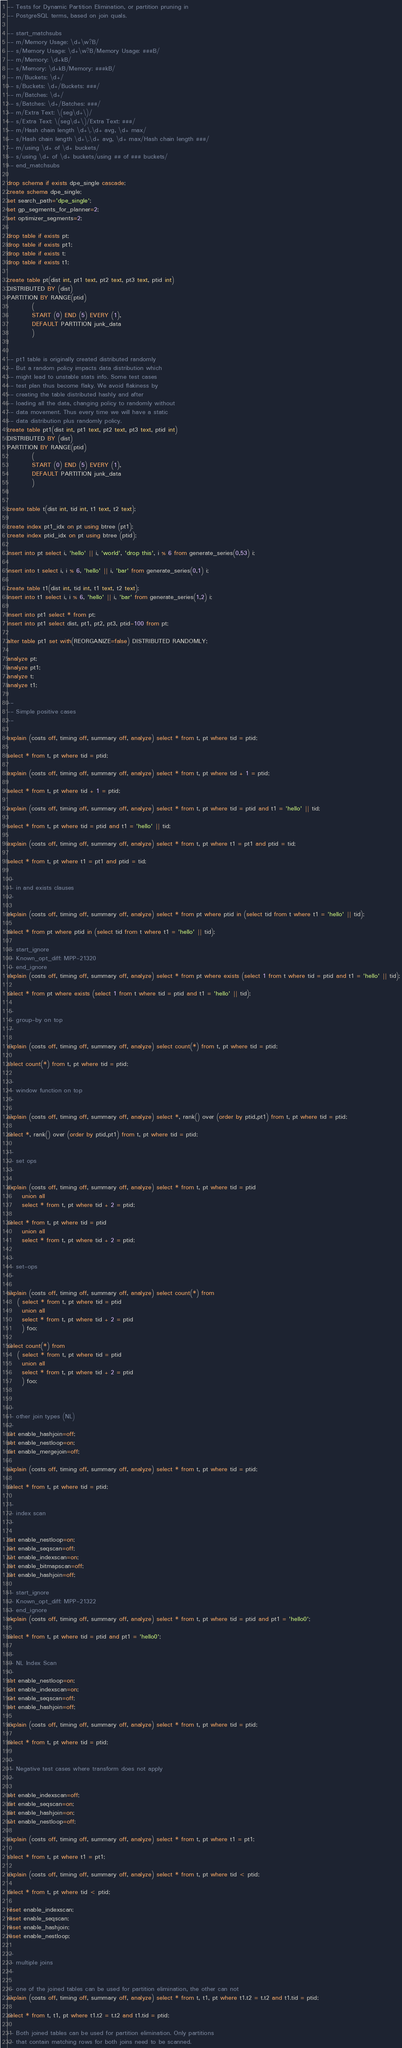Convert code to text. <code><loc_0><loc_0><loc_500><loc_500><_SQL_>-- Tests for Dynamic Partition Elimination, or partition pruning in
-- PostgreSQL terms, based on join quals.

-- start_matchsubs
-- m/Memory Usage: \d+\w?B/
-- s/Memory Usage: \d+\w?B/Memory Usage: ###B/
-- m/Memory: \d+kB/
-- s/Memory: \d+kB/Memory: ###kB/
-- m/Buckets: \d+/
-- s/Buckets: \d+/Buckets: ###/
-- m/Batches: \d+/
-- s/Batches: \d+/Batches: ###/
-- m/Extra Text: \(seg\d+\)/
-- s/Extra Text: \(seg\d+\)/Extra Text: ###/
-- m/Hash chain length \d+\.\d+ avg, \d+ max/
-- s/Hash chain length \d+\.\d+ avg, \d+ max/Hash chain length ###/
-- m/using \d+ of \d+ buckets/
-- s/using \d+ of \d+ buckets/using ## of ### buckets/
-- end_matchsubs

drop schema if exists dpe_single cascade;
create schema dpe_single;
set search_path='dpe_single';
set gp_segments_for_planner=2;
set optimizer_segments=2;

drop table if exists pt;
drop table if exists pt1;
drop table if exists t;
drop table if exists t1;

create table pt(dist int, pt1 text, pt2 text, pt3 text, ptid int) 
DISTRIBUTED BY (dist)
PARTITION BY RANGE(ptid) 
          (
          START (0) END (5) EVERY (1),
          DEFAULT PARTITION junk_data
          )
;

-- pt1 table is originally created distributed randomly
-- But a random policy impacts data distribution which
-- might lead to unstable stats info. Some test cases
-- test plan thus become flaky. We avoid flakiness by
-- creating the table distributed hashly and after
-- loading all the data, changing policy to randomly without
-- data movement. Thus every time we will have a static
-- data distribution plus randomly policy.
create table pt1(dist int, pt1 text, pt2 text, pt3 text, ptid int) 
DISTRIBUTED BY (dist)
PARTITION BY RANGE(ptid) 
          (
          START (0) END (5) EVERY (1),
          DEFAULT PARTITION junk_data
          )
;

create table t(dist int, tid int, t1 text, t2 text);

create index pt1_idx on pt using btree (pt1);
create index ptid_idx on pt using btree (ptid);

insert into pt select i, 'hello' || i, 'world', 'drop this', i % 6 from generate_series(0,53) i;

insert into t select i, i % 6, 'hello' || i, 'bar' from generate_series(0,1) i;

create table t1(dist int, tid int, t1 text, t2 text);
insert into t1 select i, i % 6, 'hello' || i, 'bar' from generate_series(1,2) i;

insert into pt1 select * from pt;
insert into pt1 select dist, pt1, pt2, pt3, ptid-100 from pt;

alter table pt1 set with(REORGANIZE=false) DISTRIBUTED RANDOMLY;

analyze pt;
analyze pt1;
analyze t;
analyze t1;

--
-- Simple positive cases
--

explain (costs off, timing off, summary off, analyze) select * from t, pt where tid = ptid;

select * from t, pt where tid = ptid;

explain (costs off, timing off, summary off, analyze) select * from t, pt where tid + 1 = ptid;

select * from t, pt where tid + 1 = ptid;

explain (costs off, timing off, summary off, analyze) select * from t, pt where tid = ptid and t1 = 'hello' || tid;

select * from t, pt where tid = ptid and t1 = 'hello' || tid;

explain (costs off, timing off, summary off, analyze) select * from t, pt where t1 = pt1 and ptid = tid;

select * from t, pt where t1 = pt1 and ptid = tid;

--
-- in and exists clauses
--

explain (costs off, timing off, summary off, analyze) select * from pt where ptid in (select tid from t where t1 = 'hello' || tid);

select * from pt where ptid in (select tid from t where t1 = 'hello' || tid);

-- start_ignore
-- Known_opt_diff: MPP-21320
-- end_ignore
explain (costs off, timing off, summary off, analyze) select * from pt where exists (select 1 from t where tid = ptid and t1 = 'hello' || tid);

select * from pt where exists (select 1 from t where tid = ptid and t1 = 'hello' || tid);

--
-- group-by on top
--

explain (costs off, timing off, summary off, analyze) select count(*) from t, pt where tid = ptid;

select count(*) from t, pt where tid = ptid;

--
-- window function on top
--

explain (costs off, timing off, summary off, analyze) select *, rank() over (order by ptid,pt1) from t, pt where tid = ptid;

select *, rank() over (order by ptid,pt1) from t, pt where tid = ptid;

--
-- set ops
--

explain (costs off, timing off, summary off, analyze) select * from t, pt where tid = ptid
	  union all
	  select * from t, pt where tid + 2 = ptid;

select * from t, pt where tid = ptid
	  union all
	  select * from t, pt where tid + 2 = ptid;

--
-- set-ops
--

explain (costs off, timing off, summary off, analyze) select count(*) from
	( select * from t, pt where tid = ptid
	  union all
	  select * from t, pt where tid + 2 = ptid
	  ) foo;

select count(*) from
	( select * from t, pt where tid = ptid
	  union all
	  select * from t, pt where tid + 2 = ptid
	  ) foo;


--
-- other join types (NL)
--
set enable_hashjoin=off;
set enable_nestloop=on;
set enable_mergejoin=off;

explain (costs off, timing off, summary off, analyze) select * from t, pt where tid = ptid;

select * from t, pt where tid = ptid;

--
-- index scan
--

set enable_nestloop=on;
set enable_seqscan=off;
set enable_indexscan=on;
set enable_bitmapscan=off;
set enable_hashjoin=off;

-- start_ignore
-- Known_opt_diff: MPP-21322
-- end_ignore
explain (costs off, timing off, summary off, analyze) select * from t, pt where tid = ptid and pt1 = 'hello0';

select * from t, pt where tid = ptid and pt1 = 'hello0';

--
-- NL Index Scan
--
set enable_nestloop=on;
set enable_indexscan=on;
set enable_seqscan=off;
set enable_hashjoin=off;

explain (costs off, timing off, summary off, analyze) select * from t, pt where tid = ptid;

select * from t, pt where tid = ptid;

--
-- Negative test cases where transform does not apply
--

set enable_indexscan=off;
set enable_seqscan=on;
set enable_hashjoin=on;
set enable_nestloop=off;

explain (costs off, timing off, summary off, analyze) select * from t, pt where t1 = pt1;

select * from t, pt where t1 = pt1;

explain (costs off, timing off, summary off, analyze) select * from t, pt where tid < ptid;

select * from t, pt where tid < ptid;

reset enable_indexscan;
reset enable_seqscan;
reset enable_hashjoin;
reset enable_nestloop;

--
-- multiple joins
--

-- one of the joined tables can be used for partition elimination, the other can not
explain (costs off, timing off, summary off, analyze) select * from t, t1, pt where t1.t2 = t.t2 and t1.tid = ptid;

select * from t, t1, pt where t1.t2 = t.t2 and t1.tid = ptid;

-- Both joined tables can be used for partition elimination. Only partitions
-- that contain matching rows for both joins need to be scanned.
</code> 